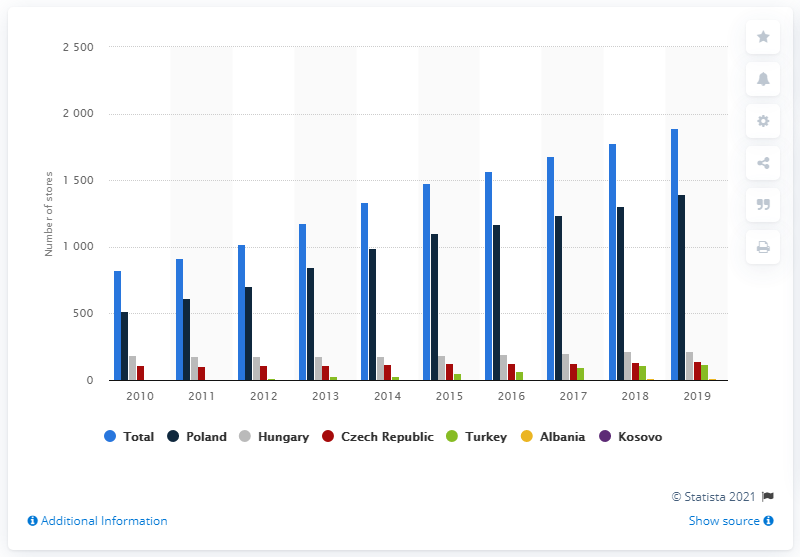Highlight a few significant elements in this photo. In 2010, Rossman expanded its presence in all of the countries shown in the graph. Poland has the largest number of Rossman stores. In January of 2019, there were 112 Rossman stores in Germany. 